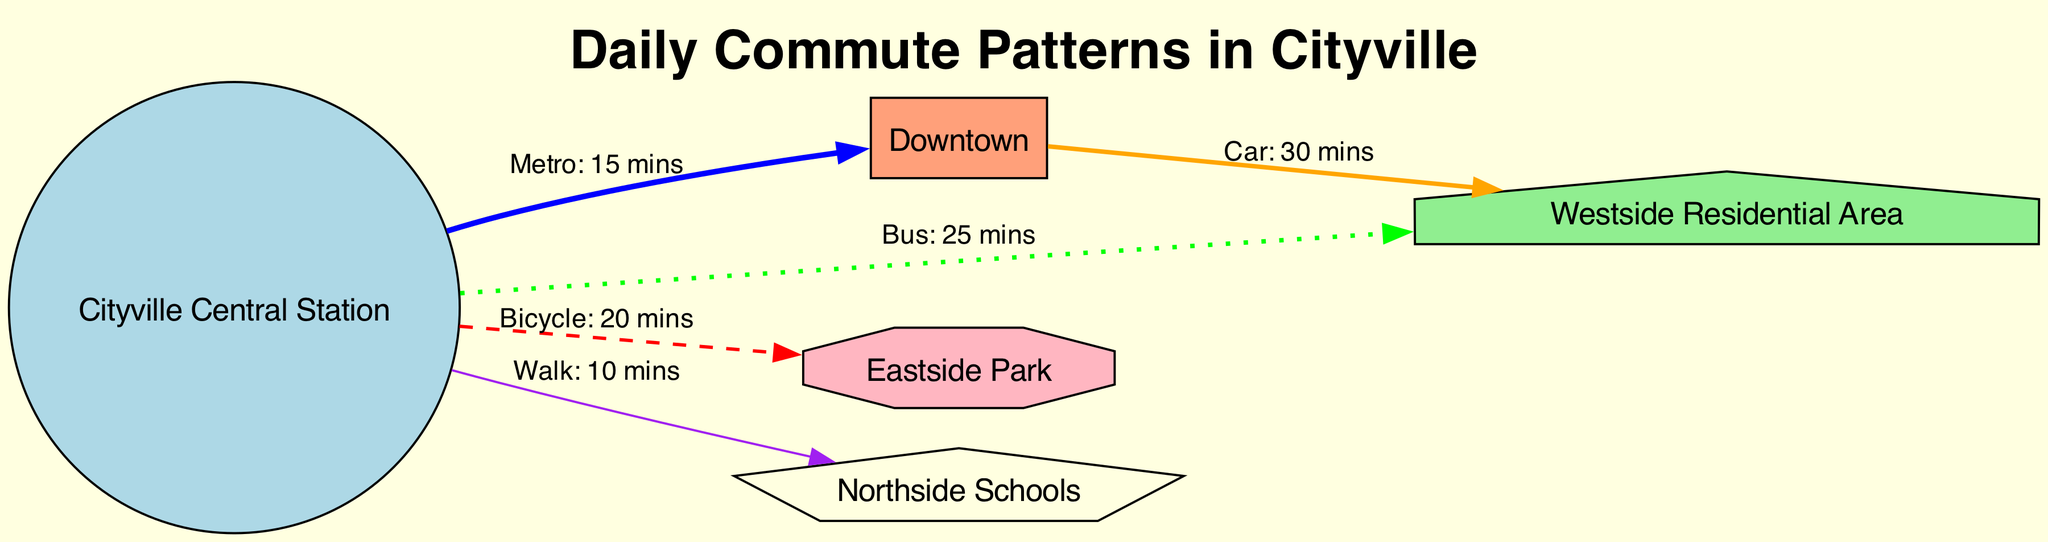What is the mode of transport from Cityville Central Station to Downtown? The diagram shows a solid line connecting Cityville Central Station to Downtown with the label "Metro: 15 mins". This indicates that the mode of transport is "Metro".
Answer: Metro What is the average commute time to the Westside Residential Area by bus? From Cityville Central Station to Westside Residential Area, the diagram indicates that the commute is by bus and is labeled "Bus: 25 mins". Therefore, the average commute time is "25 mins".
Answer: 25 mins Which landmark is associated with the shortest commute time? The diagram shows that walking from Cityville Central Station to Northside Schools takes "10 mins", which is less than any other listed commute times to the other landmarks. Thus, Northside Schools is associated with the shortest commute time.
Answer: Northside Schools What is the total number of nodes represented in the diagram? The data outlines five nodes: Cityville Central Station, Downtown, Westside Residential Area, Eastside Park, and Northside Schools. Counting these gives a total of five nodes.
Answer: 5 Which transport mode has the longest average commute time to Downtown? The transport mode from Cityville Central Station to Downtown is via Metro, which takes "15 mins". The only other mode of transport to a residential area (Westside) is by bus which takes "25 mins" (towards a different destination). Therefore, the longest commute time categorized is 30 minutes, achieved via a car from Downtown to Westside Residential Area indicating intention to reach Downtown. The answer is "Car".
Answer: Car What is the distance from Eastside Park to Cityville Central Station by bicycle? According to the diagram, there is a dashed line from Cityville Central Station to Eastside Park, labeled "Bicycle: 20 mins". This indicates that the distance via bicycle is "20 mins".
Answer: 20 mins How many edges are represented in the diagram? The diagram illustrates five edges representing connections between various nodes. By counting each labeled connection, we confirm there are five edges total.
Answer: 5 Which mode of transportation connects Downtown and Westside Residential Area? The connection between Downtown and Westside Residential Area is via a "Car", with an average commute time of "30 mins", as per the solid line connecting these two nodes.
Answer: Car What is the color associated with the mode of transport for walking? The diagram indicates that walking is represented with a purple color, as shown by the edge connecting Cityville Central Station to Northside Schools marked "Walk: 10 mins".
Answer: Purple 